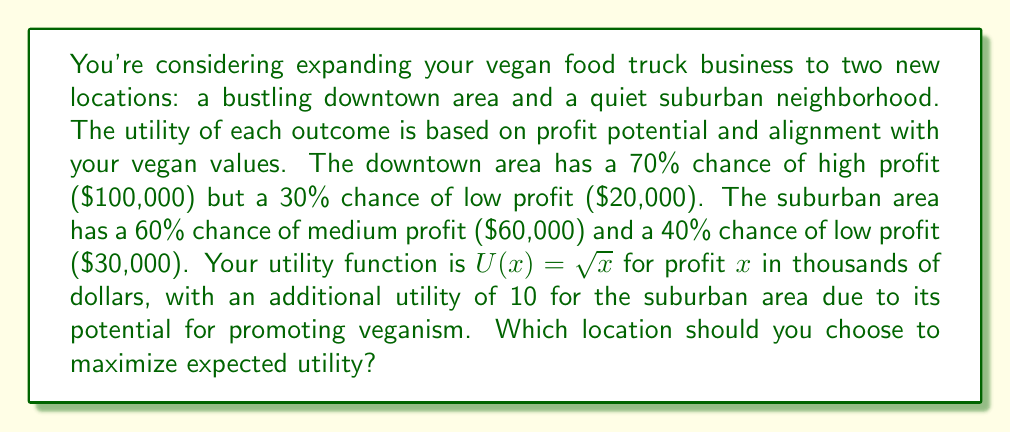Give your solution to this math problem. To solve this problem, we need to calculate the expected utility for each location and compare them:

1. Downtown Area:
   - High profit scenario: $U(100) = \sqrt{100} = 10$
   - Low profit scenario: $U(20) = \sqrt{20} \approx 4.47$
   - Expected Utility: $E[U_{downtown}] = 0.7 \cdot 10 + 0.3 \cdot 4.47 = 8.34$

2. Suburban Area:
   - Medium profit scenario: $U(60) = \sqrt{60} \approx 7.75$
   - Low profit scenario: $U(30) = \sqrt{30} \approx 5.48$
   - Additional utility for promoting veganism: 10
   - Expected Utility: $E[U_{suburban}] = (0.6 \cdot 7.75 + 0.4 \cdot 5.48) + 10 = 16.81$

The expected utility calculation for the suburban area includes the additional utility of 10 for promoting veganism, which is added to the weighted average of the profit-based utilities.

To maximize expected utility, we should choose the location with the higher expected utility value.
Answer: Choose the suburban area, as it has a higher expected utility of 16.81 compared to the downtown area's 8.34. 